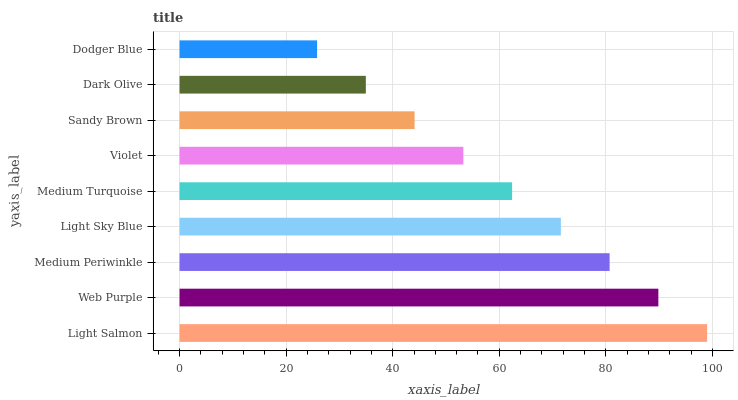Is Dodger Blue the minimum?
Answer yes or no. Yes. Is Light Salmon the maximum?
Answer yes or no. Yes. Is Web Purple the minimum?
Answer yes or no. No. Is Web Purple the maximum?
Answer yes or no. No. Is Light Salmon greater than Web Purple?
Answer yes or no. Yes. Is Web Purple less than Light Salmon?
Answer yes or no. Yes. Is Web Purple greater than Light Salmon?
Answer yes or no. No. Is Light Salmon less than Web Purple?
Answer yes or no. No. Is Medium Turquoise the high median?
Answer yes or no. Yes. Is Medium Turquoise the low median?
Answer yes or no. Yes. Is Dodger Blue the high median?
Answer yes or no. No. Is Dodger Blue the low median?
Answer yes or no. No. 